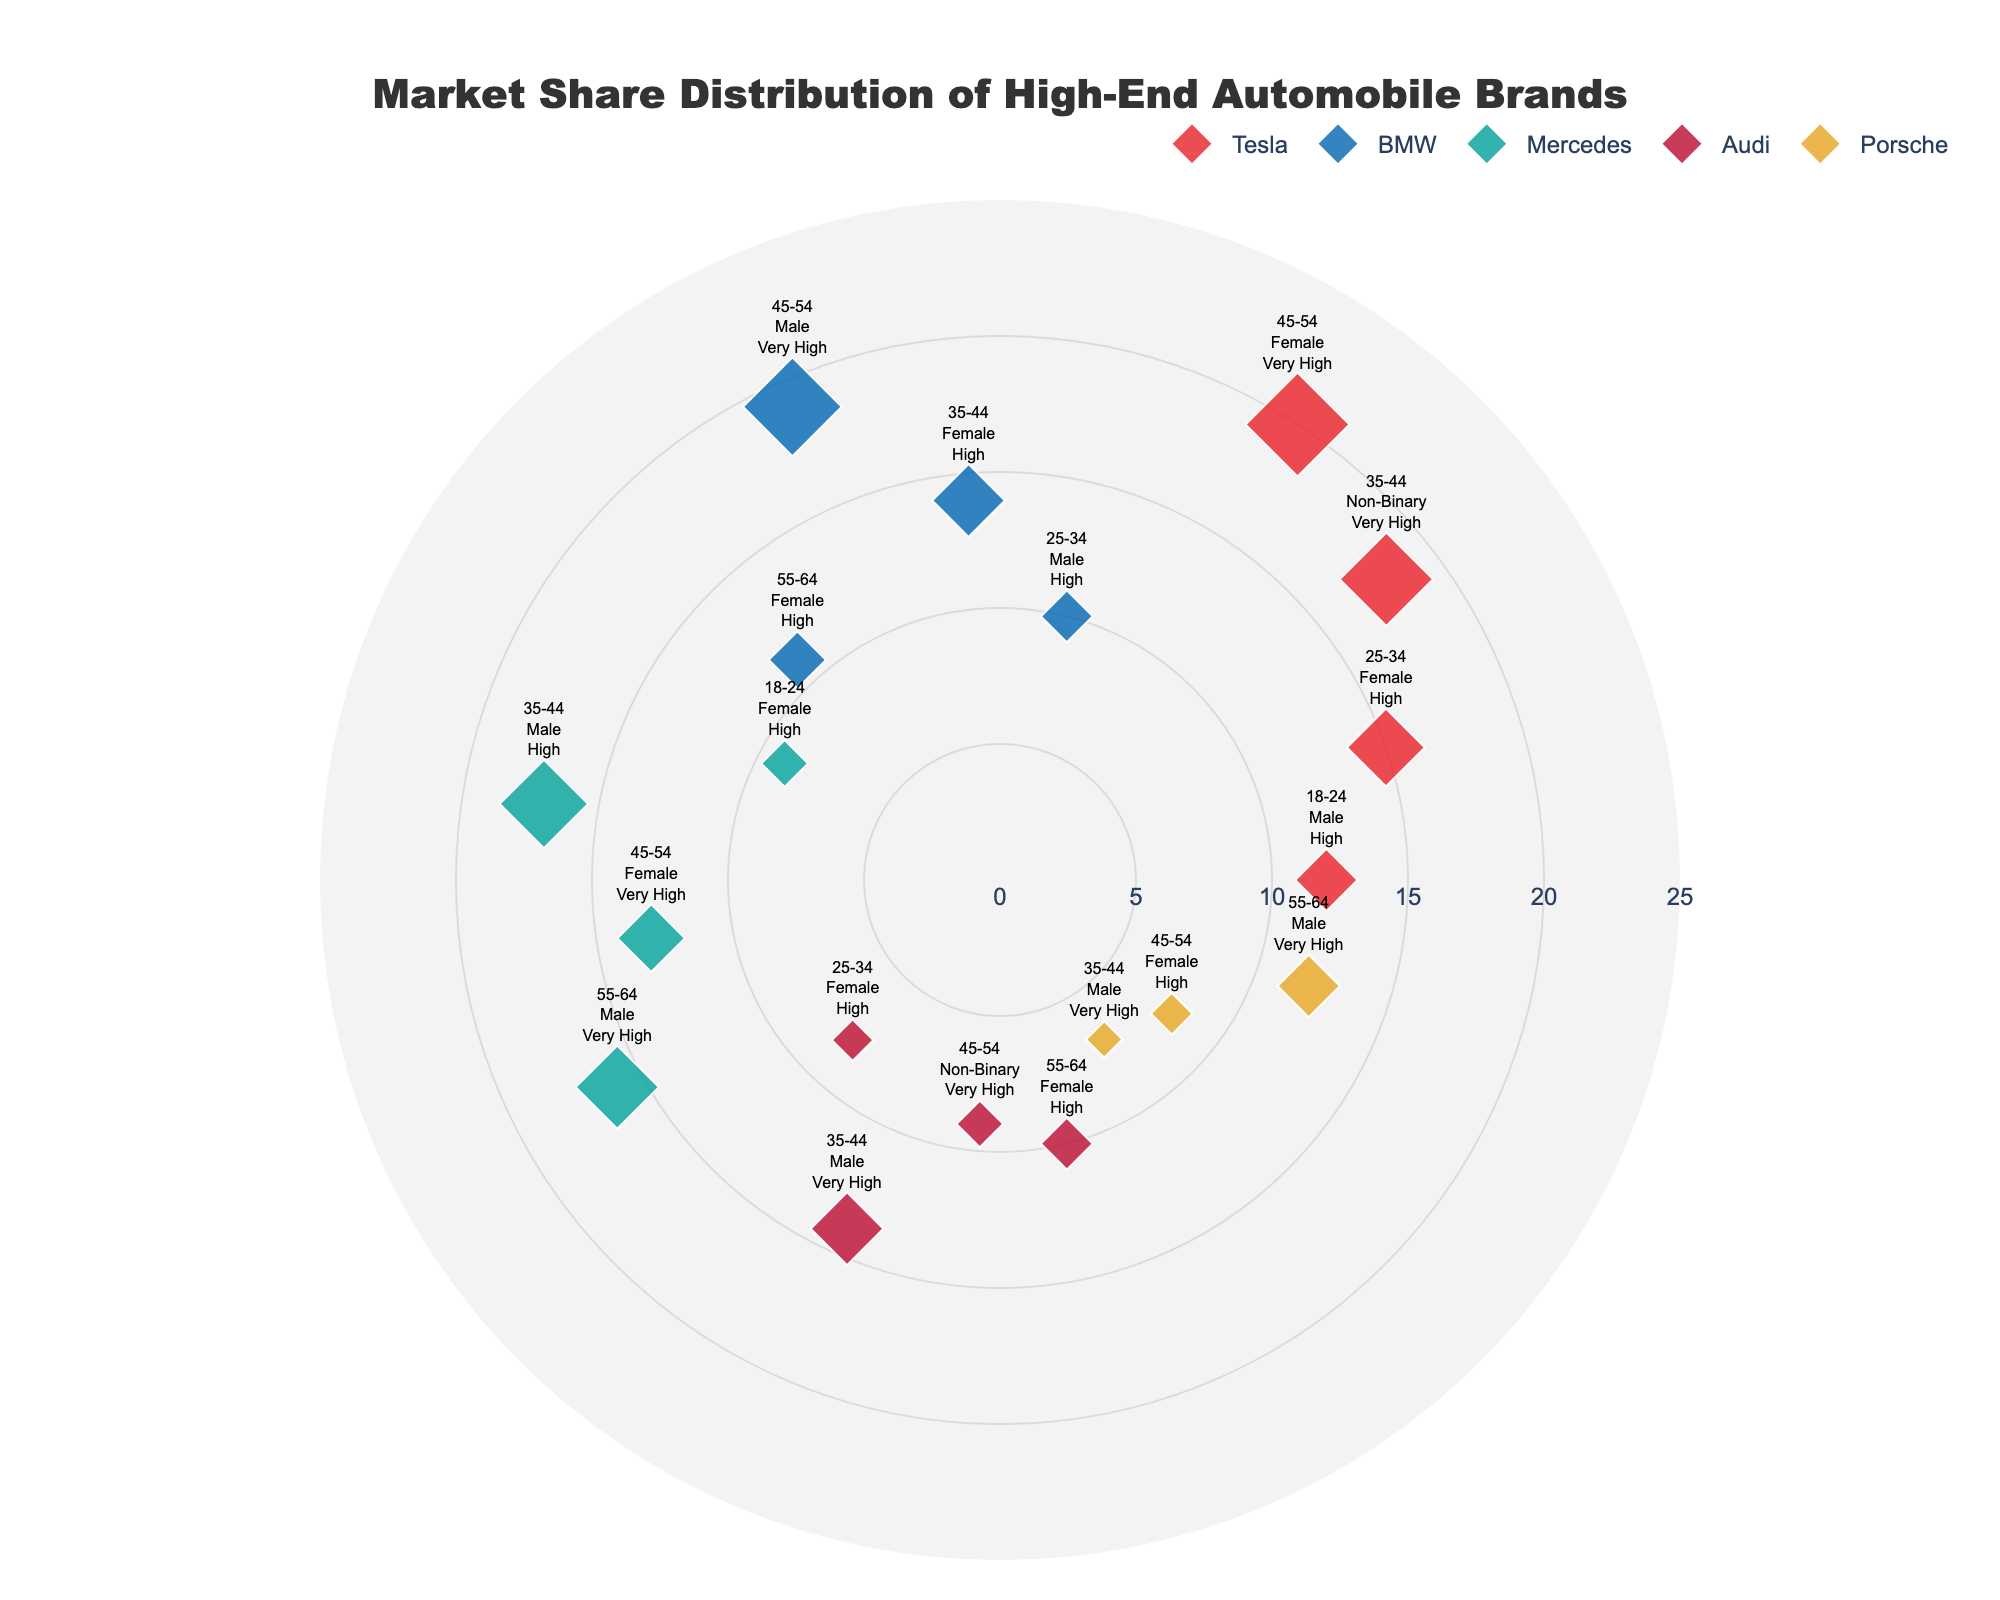What's the title of the figure? The title is usually at the top of the figure, providing a summary of what the figure represents. Here, it reads "Market Share Distribution of High-End Automobile Brands".
Answer: Market Share Distribution of High-End Automobile Brands How many brands are represented in the figure? Counting each unique brand name appearing in the legend or figure, we can identify Tesla, BMW, Mercedes, Audi, and Porsche. That makes a total of 5 brands.
Answer: 5 Which brand has the highest market share in the 45-54 age group? Reviewing the data points and looking at the market share percentages for each brand within the 45-54 age group, Tesla has the highest market share at 20%.
Answer: Tesla Among all the age groups, which brand targeting the 'Very High' income bracket has the lowest market share? First, identify the brands targeting the 'Very High' income bracket in each age group. Then compare the market share percentages among those brands. Porsche in the 35-44 age group has a market share of 7%, which is the lowest among those targeting the 'Very High' income bracket.
Answer: Porsche What's the average market share for BMW across all age groups and genders? Summing up all the market share percentages for BMW (10, 14, 19, 11) and dividing by the number of instances (4), we get an average of (10+14+19+11)/4 = 13.5.
Answer: 13.5 Compare the overall market share of Tesla and Mercedes in the 'Very High' income bracket. Which has a higher total market share? Summing the market shares for Tesla in the 'Very High' income bracket: 18 (35-44) + 20 (45-54) = 38. For Mercedes: 13 (45-54) + 16 (55-64) = 29. Tesla has a higher total market share.
Answer: Tesla Which demographic (age group, gender, and income) has the lowest market share for Audi? Identifying the market share percentages for Audi's demographics, the lowest is 8% for the 25-34 age group, Female, High income bracket.
Answer: 25-34, Female, High How many data points are represented in total? Counting each individual data point plotted in the figure, which can be done by adding the instances of each brand's category. The total count is 19 data points.
Answer: 19 What's the total market share percentage of Mercedes across all demographics? Adding up all the market share percentages for Mercedes (9, 17, 13, 16), we get a total of 9 + 17 + 13 + 16 = 55.
Answer: 55 